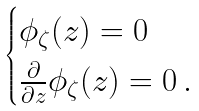<formula> <loc_0><loc_0><loc_500><loc_500>\begin{cases} \phi _ { \zeta } ( z ) = 0 \\ \frac { \partial } { \partial z } \phi _ { \zeta } ( z ) = 0 \, . \end{cases}</formula> 